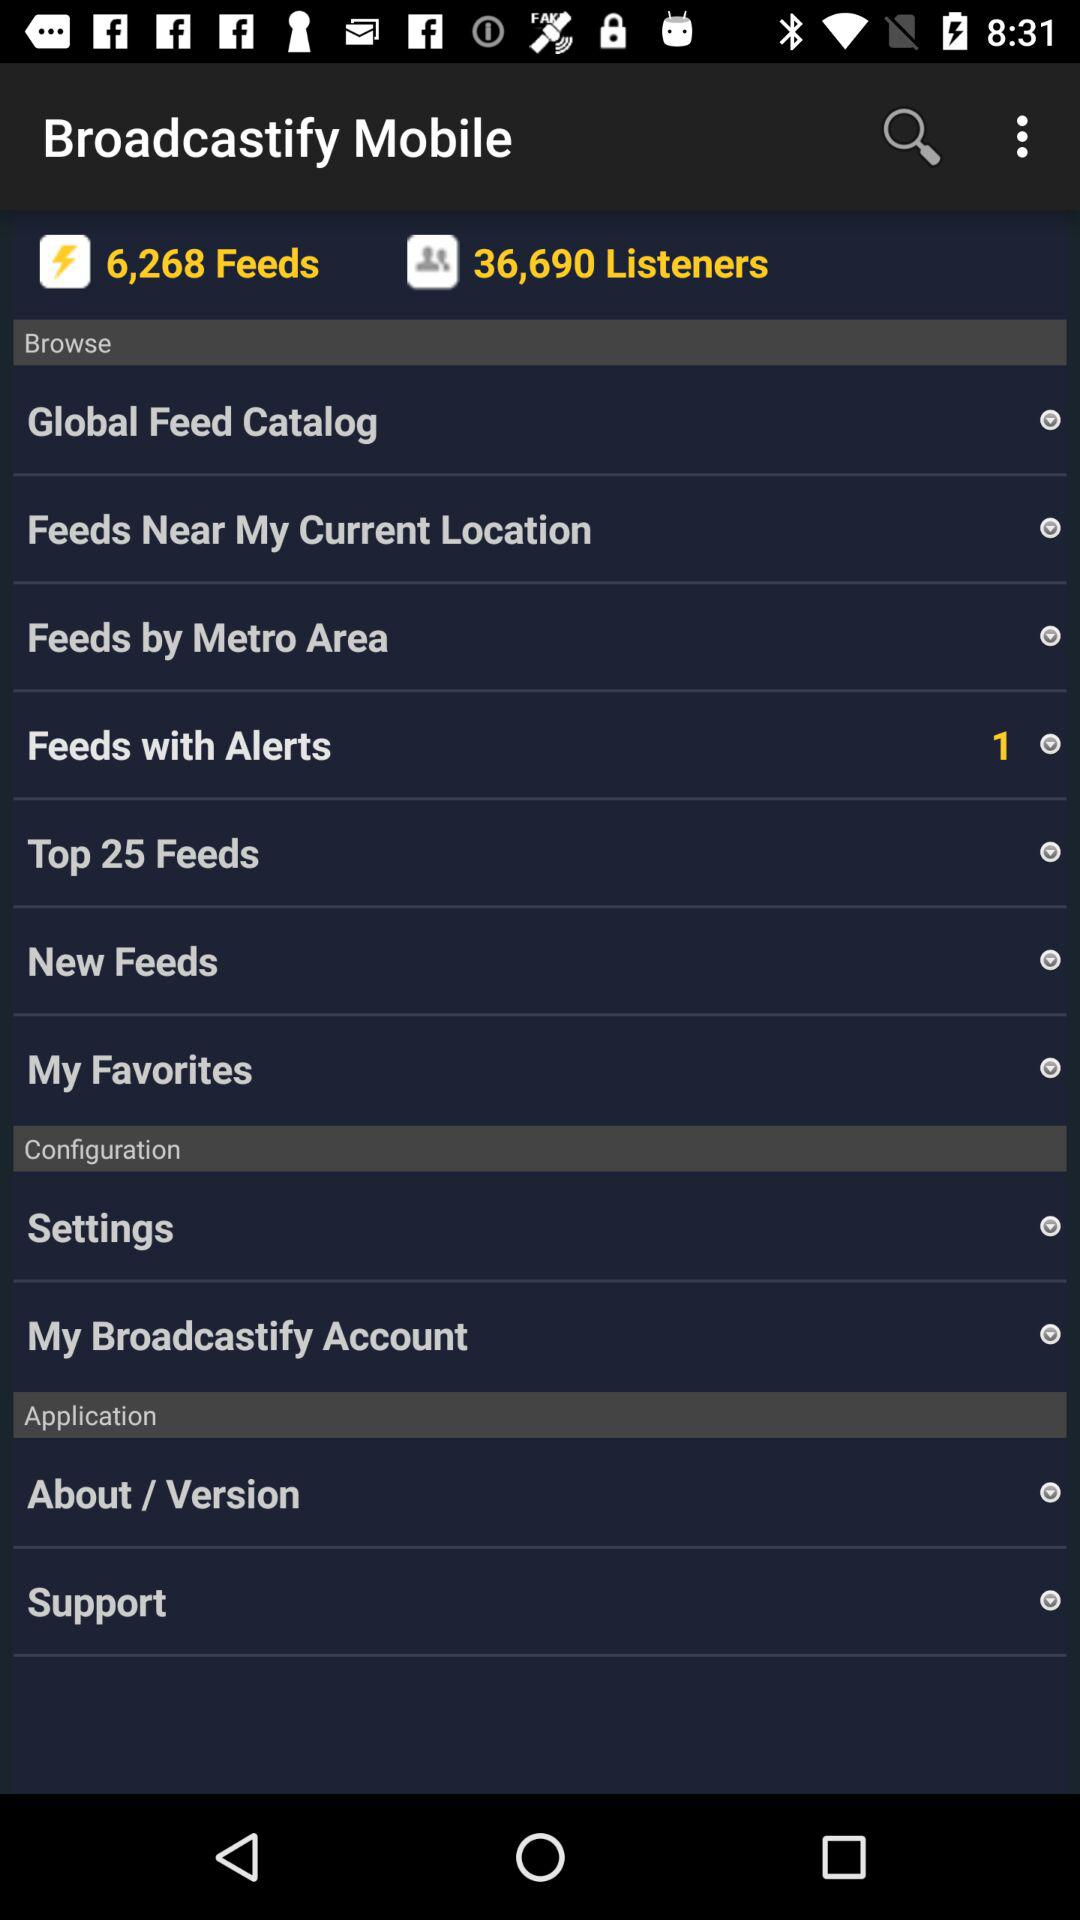What is the selected number in "Feeds with Alerts"? The selected number in "Feeds with Alerts" is 1. 